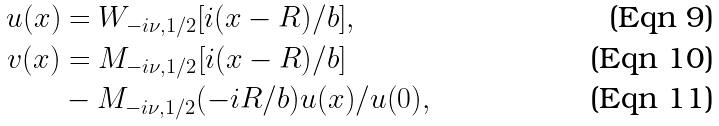<formula> <loc_0><loc_0><loc_500><loc_500>u ( x ) & = W _ { - i \nu , 1 / 2 } [ i ( x - R ) / b ] , \\ v ( x ) & = M _ { - i \nu , 1 / 2 } [ i ( x - R ) / b ] \\ & - M _ { - i \nu , 1 / 2 } ( - i R / b ) u ( x ) / u ( 0 ) ,</formula> 